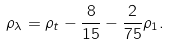<formula> <loc_0><loc_0><loc_500><loc_500>\rho _ { \lambda } = \rho _ { t } - \frac { 8 } { 1 5 } - \frac { 2 } { 7 5 } \rho _ { 1 } .</formula> 